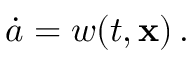<formula> <loc_0><loc_0><loc_500><loc_500>\dot { a } = w ( t , x ) \, .</formula> 